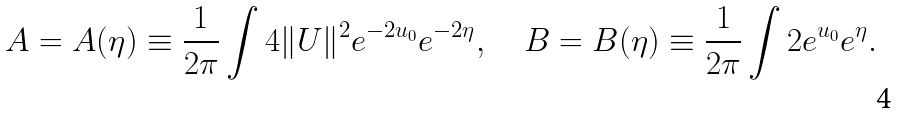<formula> <loc_0><loc_0><loc_500><loc_500>A = A ( \eta ) \equiv \frac { 1 } { 2 \pi } \int 4 \| U \| ^ { 2 } e ^ { - 2 u _ { 0 } } e ^ { - 2 \eta } , \quad B = B ( \eta ) \equiv \frac { 1 } { 2 \pi } \int 2 e ^ { u _ { 0 } } e ^ { \eta } .</formula> 